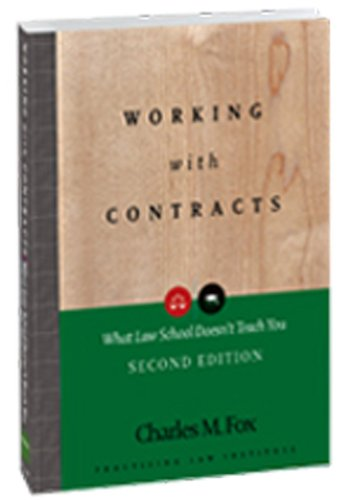What type of book is this? This is a law book, specifically focusing on the aspects of contractual agreements that are often not covered in traditional law school curricula. 